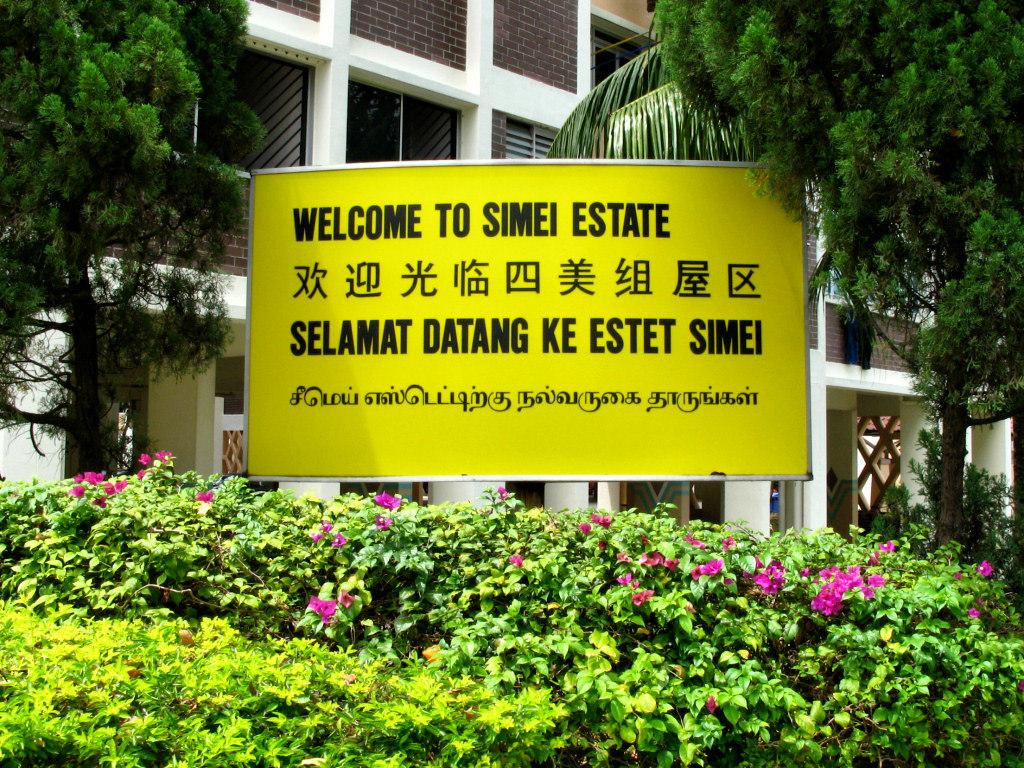What is located in the middle of the image? There is a board in the middle of the image. What can be seen in the background of the image? There are trees and a building in the background of the image. What type of vegetation is present at the bottom of the image? There are plants with pink flowers at the bottom of the image. What type of cabbage is being discussed in the news in the image? There is no reference to cabbage or news in the image, so it's not possible to determine what, if any, cabbage might be discussed. 